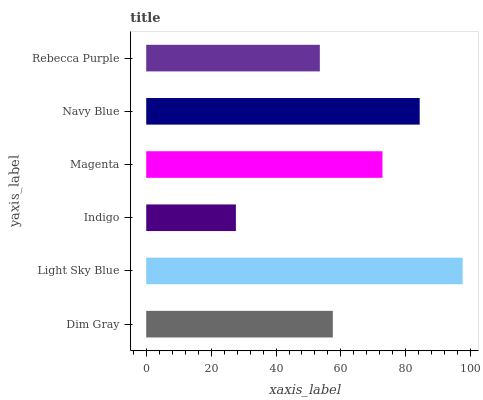Is Indigo the minimum?
Answer yes or no. Yes. Is Light Sky Blue the maximum?
Answer yes or no. Yes. Is Light Sky Blue the minimum?
Answer yes or no. No. Is Indigo the maximum?
Answer yes or no. No. Is Light Sky Blue greater than Indigo?
Answer yes or no. Yes. Is Indigo less than Light Sky Blue?
Answer yes or no. Yes. Is Indigo greater than Light Sky Blue?
Answer yes or no. No. Is Light Sky Blue less than Indigo?
Answer yes or no. No. Is Magenta the high median?
Answer yes or no. Yes. Is Dim Gray the low median?
Answer yes or no. Yes. Is Navy Blue the high median?
Answer yes or no. No. Is Rebecca Purple the low median?
Answer yes or no. No. 